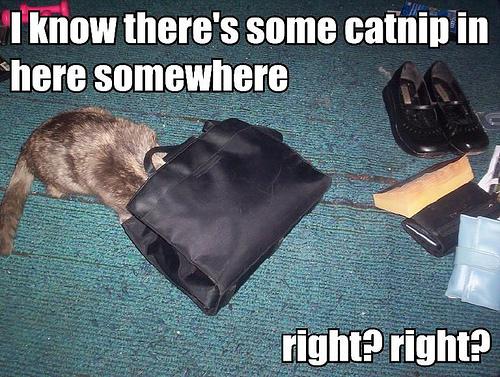What is the cat doing?
Write a very short answer. Looking in bag. Are there blue shoes in the photo?
Short answer required. No. Is the bag empty?
Keep it brief. Yes. 